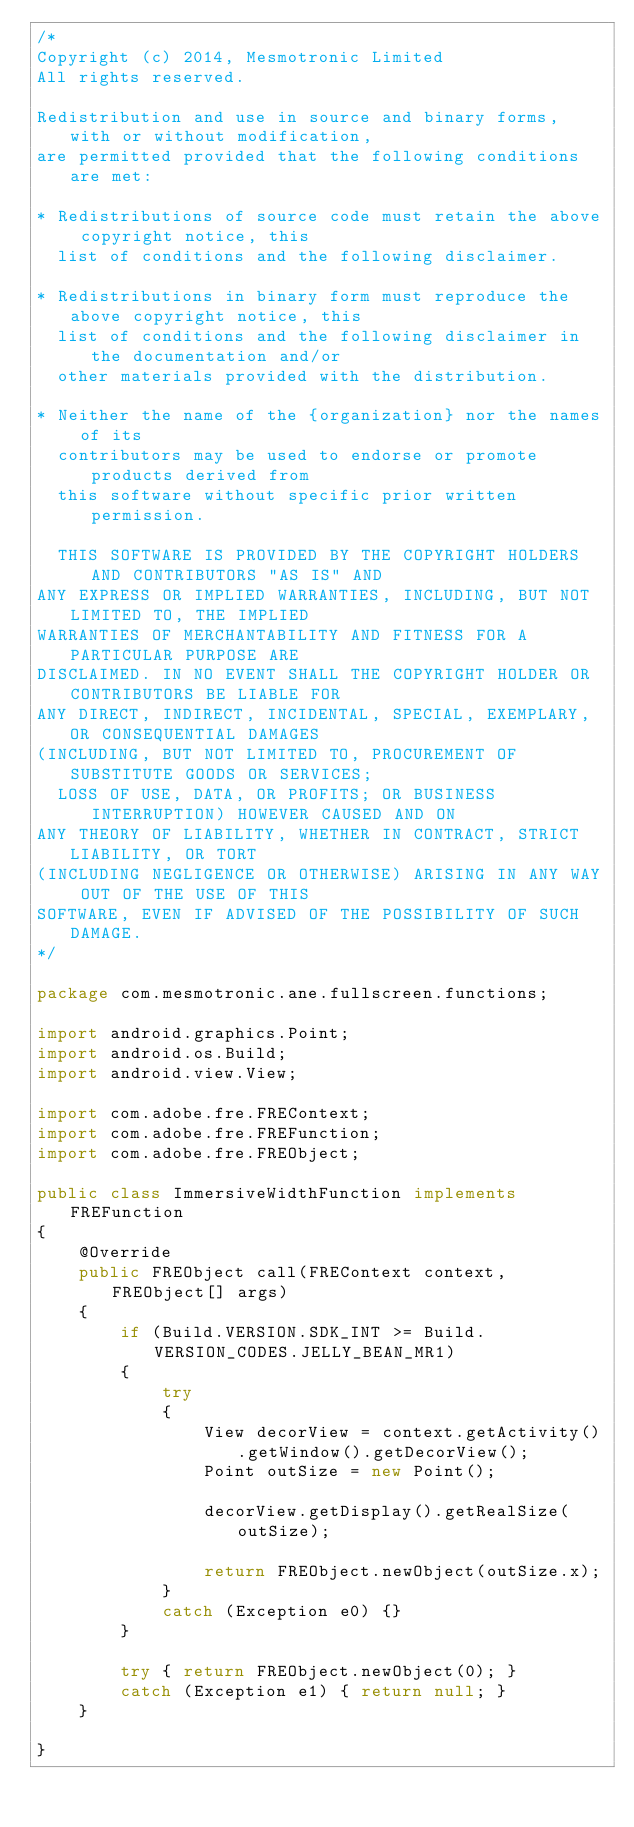Convert code to text. <code><loc_0><loc_0><loc_500><loc_500><_Java_>/*
Copyright (c) 2014, Mesmotronic Limited
All rights reserved.

Redistribution and use in source and binary forms, with or without modification,
are permitted provided that the following conditions are met:

* Redistributions of source code must retain the above copyright notice, this
  list of conditions and the following disclaimer.

* Redistributions in binary form must reproduce the above copyright notice, this
  list of conditions and the following disclaimer in the documentation and/or
  other materials provided with the distribution.
	
* Neither the name of the {organization} nor the names of its
  contributors may be used to endorse or promote products derived from
  this software without specific prior written permission.
	
  THIS SOFTWARE IS PROVIDED BY THE COPYRIGHT HOLDERS AND CONTRIBUTORS "AS IS" AND
ANY EXPRESS OR IMPLIED WARRANTIES, INCLUDING, BUT NOT LIMITED TO, THE IMPLIED
WARRANTIES OF MERCHANTABILITY AND FITNESS FOR A PARTICULAR PURPOSE ARE
DISCLAIMED. IN NO EVENT SHALL THE COPYRIGHT HOLDER OR CONTRIBUTORS BE LIABLE FOR
ANY DIRECT, INDIRECT, INCIDENTAL, SPECIAL, EXEMPLARY, OR CONSEQUENTIAL DAMAGES
(INCLUDING, BUT NOT LIMITED TO, PROCUREMENT OF SUBSTITUTE GOODS OR SERVICES;
  LOSS OF USE, DATA, OR PROFITS; OR BUSINESS INTERRUPTION) HOWEVER CAUSED AND ON
ANY THEORY OF LIABILITY, WHETHER IN CONTRACT, STRICT LIABILITY, OR TORT
(INCLUDING NEGLIGENCE OR OTHERWISE) ARISING IN ANY WAY OUT OF THE USE OF THIS
SOFTWARE, EVEN IF ADVISED OF THE POSSIBILITY OF SUCH DAMAGE.
*/

package com.mesmotronic.ane.fullscreen.functions;

import android.graphics.Point;
import android.os.Build;
import android.view.View;

import com.adobe.fre.FREContext;
import com.adobe.fre.FREFunction;
import com.adobe.fre.FREObject;

public class ImmersiveWidthFunction implements FREFunction 
{
	@Override
	public FREObject call(FREContext context, FREObject[] args) 
	{
		if (Build.VERSION.SDK_INT >= Build.VERSION_CODES.JELLY_BEAN_MR1)
		{
			try
			{
				View decorView = context.getActivity().getWindow().getDecorView();
				Point outSize = new Point();
				
				decorView.getDisplay().getRealSize(outSize);
				
				return FREObject.newObject(outSize.x);
			}
			catch (Exception e0) {} 
		}
		
		try { return FREObject.newObject(0); }
		catch (Exception e1) { return null; }
	}
	
}
</code> 